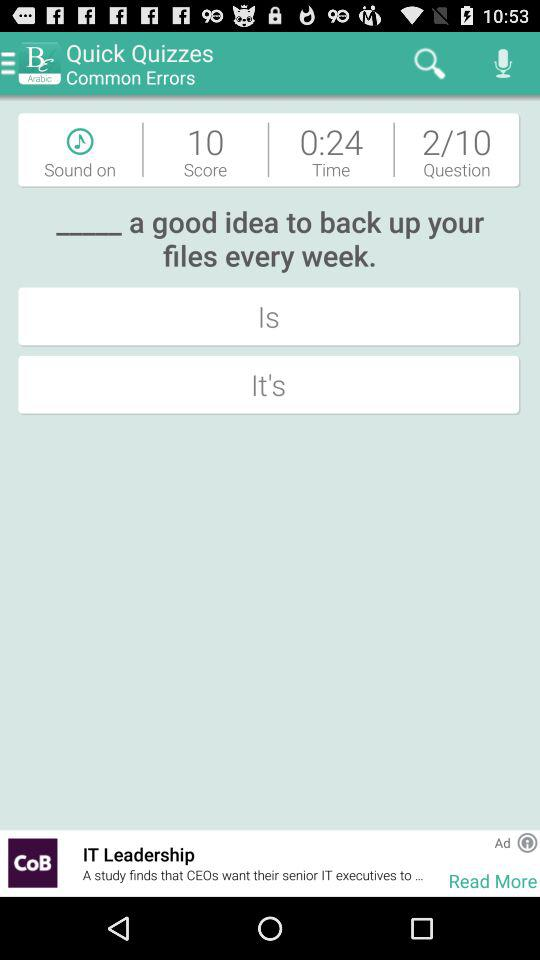What is the name of the application? The name of the application is "Britannica English". 